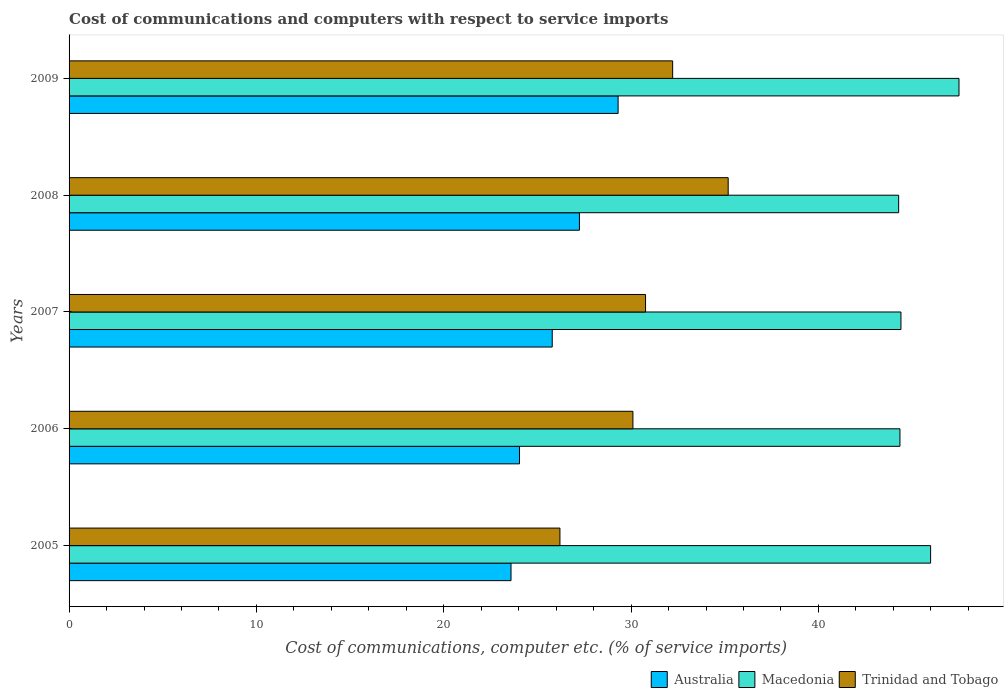How many groups of bars are there?
Your response must be concise. 5. How many bars are there on the 3rd tick from the top?
Keep it short and to the point. 3. What is the cost of communications and computers in Trinidad and Tobago in 2009?
Give a very brief answer. 32.22. Across all years, what is the maximum cost of communications and computers in Macedonia?
Ensure brevity in your answer.  47.51. Across all years, what is the minimum cost of communications and computers in Australia?
Ensure brevity in your answer.  23.59. What is the total cost of communications and computers in Trinidad and Tobago in the graph?
Offer a terse response. 154.48. What is the difference between the cost of communications and computers in Macedonia in 2007 and that in 2008?
Provide a short and direct response. 0.12. What is the difference between the cost of communications and computers in Trinidad and Tobago in 2006 and the cost of communications and computers in Australia in 2005?
Keep it short and to the point. 6.51. What is the average cost of communications and computers in Australia per year?
Your response must be concise. 26. In the year 2009, what is the difference between the cost of communications and computers in Australia and cost of communications and computers in Trinidad and Tobago?
Your answer should be compact. -2.91. What is the ratio of the cost of communications and computers in Australia in 2006 to that in 2009?
Keep it short and to the point. 0.82. Is the cost of communications and computers in Trinidad and Tobago in 2006 less than that in 2009?
Provide a short and direct response. Yes. Is the difference between the cost of communications and computers in Australia in 2007 and 2009 greater than the difference between the cost of communications and computers in Trinidad and Tobago in 2007 and 2009?
Provide a succinct answer. No. What is the difference between the highest and the second highest cost of communications and computers in Australia?
Give a very brief answer. 2.06. What is the difference between the highest and the lowest cost of communications and computers in Macedonia?
Keep it short and to the point. 3.22. In how many years, is the cost of communications and computers in Trinidad and Tobago greater than the average cost of communications and computers in Trinidad and Tobago taken over all years?
Keep it short and to the point. 2. Is the sum of the cost of communications and computers in Macedonia in 2005 and 2006 greater than the maximum cost of communications and computers in Trinidad and Tobago across all years?
Offer a terse response. Yes. What does the 2nd bar from the top in 2009 represents?
Your answer should be compact. Macedonia. What does the 2nd bar from the bottom in 2009 represents?
Keep it short and to the point. Macedonia. How many bars are there?
Keep it short and to the point. 15. How many years are there in the graph?
Provide a short and direct response. 5. Does the graph contain any zero values?
Provide a succinct answer. No. Does the graph contain grids?
Provide a short and direct response. No. How many legend labels are there?
Your answer should be compact. 3. How are the legend labels stacked?
Offer a terse response. Horizontal. What is the title of the graph?
Offer a terse response. Cost of communications and computers with respect to service imports. What is the label or title of the X-axis?
Keep it short and to the point. Cost of communications, computer etc. (% of service imports). What is the Cost of communications, computer etc. (% of service imports) in Australia in 2005?
Your response must be concise. 23.59. What is the Cost of communications, computer etc. (% of service imports) in Macedonia in 2005?
Your answer should be very brief. 45.99. What is the Cost of communications, computer etc. (% of service imports) in Trinidad and Tobago in 2005?
Offer a terse response. 26.2. What is the Cost of communications, computer etc. (% of service imports) of Australia in 2006?
Your answer should be very brief. 24.05. What is the Cost of communications, computer etc. (% of service imports) of Macedonia in 2006?
Ensure brevity in your answer.  44.35. What is the Cost of communications, computer etc. (% of service imports) in Trinidad and Tobago in 2006?
Your response must be concise. 30.1. What is the Cost of communications, computer etc. (% of service imports) of Australia in 2007?
Your answer should be very brief. 25.79. What is the Cost of communications, computer etc. (% of service imports) of Macedonia in 2007?
Your response must be concise. 44.41. What is the Cost of communications, computer etc. (% of service imports) in Trinidad and Tobago in 2007?
Your answer should be very brief. 30.77. What is the Cost of communications, computer etc. (% of service imports) of Australia in 2008?
Your answer should be compact. 27.24. What is the Cost of communications, computer etc. (% of service imports) in Macedonia in 2008?
Provide a succinct answer. 44.28. What is the Cost of communications, computer etc. (% of service imports) of Trinidad and Tobago in 2008?
Keep it short and to the point. 35.18. What is the Cost of communications, computer etc. (% of service imports) in Australia in 2009?
Offer a very short reply. 29.31. What is the Cost of communications, computer etc. (% of service imports) in Macedonia in 2009?
Your answer should be very brief. 47.51. What is the Cost of communications, computer etc. (% of service imports) in Trinidad and Tobago in 2009?
Offer a terse response. 32.22. Across all years, what is the maximum Cost of communications, computer etc. (% of service imports) of Australia?
Your response must be concise. 29.31. Across all years, what is the maximum Cost of communications, computer etc. (% of service imports) in Macedonia?
Offer a very short reply. 47.51. Across all years, what is the maximum Cost of communications, computer etc. (% of service imports) in Trinidad and Tobago?
Your answer should be very brief. 35.18. Across all years, what is the minimum Cost of communications, computer etc. (% of service imports) in Australia?
Keep it short and to the point. 23.59. Across all years, what is the minimum Cost of communications, computer etc. (% of service imports) of Macedonia?
Provide a succinct answer. 44.28. Across all years, what is the minimum Cost of communications, computer etc. (% of service imports) of Trinidad and Tobago?
Give a very brief answer. 26.2. What is the total Cost of communications, computer etc. (% of service imports) of Australia in the graph?
Give a very brief answer. 129.98. What is the total Cost of communications, computer etc. (% of service imports) of Macedonia in the graph?
Your answer should be compact. 226.54. What is the total Cost of communications, computer etc. (% of service imports) in Trinidad and Tobago in the graph?
Keep it short and to the point. 154.48. What is the difference between the Cost of communications, computer etc. (% of service imports) in Australia in 2005 and that in 2006?
Provide a short and direct response. -0.45. What is the difference between the Cost of communications, computer etc. (% of service imports) of Macedonia in 2005 and that in 2006?
Offer a very short reply. 1.64. What is the difference between the Cost of communications, computer etc. (% of service imports) of Trinidad and Tobago in 2005 and that in 2006?
Offer a very short reply. -3.9. What is the difference between the Cost of communications, computer etc. (% of service imports) of Australia in 2005 and that in 2007?
Provide a short and direct response. -2.2. What is the difference between the Cost of communications, computer etc. (% of service imports) of Macedonia in 2005 and that in 2007?
Offer a terse response. 1.58. What is the difference between the Cost of communications, computer etc. (% of service imports) of Trinidad and Tobago in 2005 and that in 2007?
Make the answer very short. -4.57. What is the difference between the Cost of communications, computer etc. (% of service imports) in Australia in 2005 and that in 2008?
Give a very brief answer. -3.65. What is the difference between the Cost of communications, computer etc. (% of service imports) in Macedonia in 2005 and that in 2008?
Provide a short and direct response. 1.71. What is the difference between the Cost of communications, computer etc. (% of service imports) of Trinidad and Tobago in 2005 and that in 2008?
Provide a short and direct response. -8.98. What is the difference between the Cost of communications, computer etc. (% of service imports) of Australia in 2005 and that in 2009?
Offer a terse response. -5.72. What is the difference between the Cost of communications, computer etc. (% of service imports) in Macedonia in 2005 and that in 2009?
Your response must be concise. -1.51. What is the difference between the Cost of communications, computer etc. (% of service imports) of Trinidad and Tobago in 2005 and that in 2009?
Offer a very short reply. -6.02. What is the difference between the Cost of communications, computer etc. (% of service imports) in Australia in 2006 and that in 2007?
Ensure brevity in your answer.  -1.75. What is the difference between the Cost of communications, computer etc. (% of service imports) of Macedonia in 2006 and that in 2007?
Provide a short and direct response. -0.05. What is the difference between the Cost of communications, computer etc. (% of service imports) in Trinidad and Tobago in 2006 and that in 2007?
Give a very brief answer. -0.67. What is the difference between the Cost of communications, computer etc. (% of service imports) of Australia in 2006 and that in 2008?
Offer a very short reply. -3.2. What is the difference between the Cost of communications, computer etc. (% of service imports) in Macedonia in 2006 and that in 2008?
Your answer should be compact. 0.07. What is the difference between the Cost of communications, computer etc. (% of service imports) in Trinidad and Tobago in 2006 and that in 2008?
Offer a terse response. -5.08. What is the difference between the Cost of communications, computer etc. (% of service imports) of Australia in 2006 and that in 2009?
Offer a terse response. -5.26. What is the difference between the Cost of communications, computer etc. (% of service imports) of Macedonia in 2006 and that in 2009?
Provide a succinct answer. -3.15. What is the difference between the Cost of communications, computer etc. (% of service imports) in Trinidad and Tobago in 2006 and that in 2009?
Provide a succinct answer. -2.12. What is the difference between the Cost of communications, computer etc. (% of service imports) of Australia in 2007 and that in 2008?
Make the answer very short. -1.45. What is the difference between the Cost of communications, computer etc. (% of service imports) in Macedonia in 2007 and that in 2008?
Keep it short and to the point. 0.12. What is the difference between the Cost of communications, computer etc. (% of service imports) of Trinidad and Tobago in 2007 and that in 2008?
Keep it short and to the point. -4.41. What is the difference between the Cost of communications, computer etc. (% of service imports) of Australia in 2007 and that in 2009?
Make the answer very short. -3.52. What is the difference between the Cost of communications, computer etc. (% of service imports) of Macedonia in 2007 and that in 2009?
Provide a succinct answer. -3.1. What is the difference between the Cost of communications, computer etc. (% of service imports) in Trinidad and Tobago in 2007 and that in 2009?
Keep it short and to the point. -1.45. What is the difference between the Cost of communications, computer etc. (% of service imports) in Australia in 2008 and that in 2009?
Provide a succinct answer. -2.06. What is the difference between the Cost of communications, computer etc. (% of service imports) of Macedonia in 2008 and that in 2009?
Your answer should be compact. -3.22. What is the difference between the Cost of communications, computer etc. (% of service imports) of Trinidad and Tobago in 2008 and that in 2009?
Offer a terse response. 2.96. What is the difference between the Cost of communications, computer etc. (% of service imports) of Australia in 2005 and the Cost of communications, computer etc. (% of service imports) of Macedonia in 2006?
Provide a succinct answer. -20.76. What is the difference between the Cost of communications, computer etc. (% of service imports) in Australia in 2005 and the Cost of communications, computer etc. (% of service imports) in Trinidad and Tobago in 2006?
Ensure brevity in your answer.  -6.51. What is the difference between the Cost of communications, computer etc. (% of service imports) in Macedonia in 2005 and the Cost of communications, computer etc. (% of service imports) in Trinidad and Tobago in 2006?
Your answer should be compact. 15.89. What is the difference between the Cost of communications, computer etc. (% of service imports) of Australia in 2005 and the Cost of communications, computer etc. (% of service imports) of Macedonia in 2007?
Provide a succinct answer. -20.81. What is the difference between the Cost of communications, computer etc. (% of service imports) in Australia in 2005 and the Cost of communications, computer etc. (% of service imports) in Trinidad and Tobago in 2007?
Provide a short and direct response. -7.18. What is the difference between the Cost of communications, computer etc. (% of service imports) of Macedonia in 2005 and the Cost of communications, computer etc. (% of service imports) of Trinidad and Tobago in 2007?
Keep it short and to the point. 15.22. What is the difference between the Cost of communications, computer etc. (% of service imports) in Australia in 2005 and the Cost of communications, computer etc. (% of service imports) in Macedonia in 2008?
Keep it short and to the point. -20.69. What is the difference between the Cost of communications, computer etc. (% of service imports) of Australia in 2005 and the Cost of communications, computer etc. (% of service imports) of Trinidad and Tobago in 2008?
Ensure brevity in your answer.  -11.59. What is the difference between the Cost of communications, computer etc. (% of service imports) of Macedonia in 2005 and the Cost of communications, computer etc. (% of service imports) of Trinidad and Tobago in 2008?
Make the answer very short. 10.81. What is the difference between the Cost of communications, computer etc. (% of service imports) of Australia in 2005 and the Cost of communications, computer etc. (% of service imports) of Macedonia in 2009?
Ensure brevity in your answer.  -23.91. What is the difference between the Cost of communications, computer etc. (% of service imports) of Australia in 2005 and the Cost of communications, computer etc. (% of service imports) of Trinidad and Tobago in 2009?
Your answer should be very brief. -8.63. What is the difference between the Cost of communications, computer etc. (% of service imports) in Macedonia in 2005 and the Cost of communications, computer etc. (% of service imports) in Trinidad and Tobago in 2009?
Offer a terse response. 13.77. What is the difference between the Cost of communications, computer etc. (% of service imports) of Australia in 2006 and the Cost of communications, computer etc. (% of service imports) of Macedonia in 2007?
Keep it short and to the point. -20.36. What is the difference between the Cost of communications, computer etc. (% of service imports) of Australia in 2006 and the Cost of communications, computer etc. (% of service imports) of Trinidad and Tobago in 2007?
Provide a short and direct response. -6.73. What is the difference between the Cost of communications, computer etc. (% of service imports) in Macedonia in 2006 and the Cost of communications, computer etc. (% of service imports) in Trinidad and Tobago in 2007?
Ensure brevity in your answer.  13.58. What is the difference between the Cost of communications, computer etc. (% of service imports) of Australia in 2006 and the Cost of communications, computer etc. (% of service imports) of Macedonia in 2008?
Your response must be concise. -20.24. What is the difference between the Cost of communications, computer etc. (% of service imports) in Australia in 2006 and the Cost of communications, computer etc. (% of service imports) in Trinidad and Tobago in 2008?
Ensure brevity in your answer.  -11.14. What is the difference between the Cost of communications, computer etc. (% of service imports) in Macedonia in 2006 and the Cost of communications, computer etc. (% of service imports) in Trinidad and Tobago in 2008?
Provide a short and direct response. 9.17. What is the difference between the Cost of communications, computer etc. (% of service imports) of Australia in 2006 and the Cost of communications, computer etc. (% of service imports) of Macedonia in 2009?
Ensure brevity in your answer.  -23.46. What is the difference between the Cost of communications, computer etc. (% of service imports) in Australia in 2006 and the Cost of communications, computer etc. (% of service imports) in Trinidad and Tobago in 2009?
Provide a succinct answer. -8.17. What is the difference between the Cost of communications, computer etc. (% of service imports) of Macedonia in 2006 and the Cost of communications, computer etc. (% of service imports) of Trinidad and Tobago in 2009?
Provide a short and direct response. 12.13. What is the difference between the Cost of communications, computer etc. (% of service imports) of Australia in 2007 and the Cost of communications, computer etc. (% of service imports) of Macedonia in 2008?
Provide a short and direct response. -18.49. What is the difference between the Cost of communications, computer etc. (% of service imports) of Australia in 2007 and the Cost of communications, computer etc. (% of service imports) of Trinidad and Tobago in 2008?
Provide a short and direct response. -9.39. What is the difference between the Cost of communications, computer etc. (% of service imports) of Macedonia in 2007 and the Cost of communications, computer etc. (% of service imports) of Trinidad and Tobago in 2008?
Offer a very short reply. 9.22. What is the difference between the Cost of communications, computer etc. (% of service imports) of Australia in 2007 and the Cost of communications, computer etc. (% of service imports) of Macedonia in 2009?
Provide a short and direct response. -21.71. What is the difference between the Cost of communications, computer etc. (% of service imports) in Australia in 2007 and the Cost of communications, computer etc. (% of service imports) in Trinidad and Tobago in 2009?
Keep it short and to the point. -6.43. What is the difference between the Cost of communications, computer etc. (% of service imports) of Macedonia in 2007 and the Cost of communications, computer etc. (% of service imports) of Trinidad and Tobago in 2009?
Offer a terse response. 12.19. What is the difference between the Cost of communications, computer etc. (% of service imports) in Australia in 2008 and the Cost of communications, computer etc. (% of service imports) in Macedonia in 2009?
Make the answer very short. -20.26. What is the difference between the Cost of communications, computer etc. (% of service imports) of Australia in 2008 and the Cost of communications, computer etc. (% of service imports) of Trinidad and Tobago in 2009?
Your response must be concise. -4.98. What is the difference between the Cost of communications, computer etc. (% of service imports) of Macedonia in 2008 and the Cost of communications, computer etc. (% of service imports) of Trinidad and Tobago in 2009?
Keep it short and to the point. 12.06. What is the average Cost of communications, computer etc. (% of service imports) of Australia per year?
Ensure brevity in your answer.  26. What is the average Cost of communications, computer etc. (% of service imports) in Macedonia per year?
Your answer should be compact. 45.31. What is the average Cost of communications, computer etc. (% of service imports) of Trinidad and Tobago per year?
Offer a very short reply. 30.9. In the year 2005, what is the difference between the Cost of communications, computer etc. (% of service imports) in Australia and Cost of communications, computer etc. (% of service imports) in Macedonia?
Make the answer very short. -22.4. In the year 2005, what is the difference between the Cost of communications, computer etc. (% of service imports) in Australia and Cost of communications, computer etc. (% of service imports) in Trinidad and Tobago?
Offer a terse response. -2.61. In the year 2005, what is the difference between the Cost of communications, computer etc. (% of service imports) in Macedonia and Cost of communications, computer etc. (% of service imports) in Trinidad and Tobago?
Keep it short and to the point. 19.79. In the year 2006, what is the difference between the Cost of communications, computer etc. (% of service imports) in Australia and Cost of communications, computer etc. (% of service imports) in Macedonia?
Ensure brevity in your answer.  -20.31. In the year 2006, what is the difference between the Cost of communications, computer etc. (% of service imports) of Australia and Cost of communications, computer etc. (% of service imports) of Trinidad and Tobago?
Provide a short and direct response. -6.05. In the year 2006, what is the difference between the Cost of communications, computer etc. (% of service imports) in Macedonia and Cost of communications, computer etc. (% of service imports) in Trinidad and Tobago?
Provide a short and direct response. 14.25. In the year 2007, what is the difference between the Cost of communications, computer etc. (% of service imports) in Australia and Cost of communications, computer etc. (% of service imports) in Macedonia?
Your answer should be compact. -18.61. In the year 2007, what is the difference between the Cost of communications, computer etc. (% of service imports) of Australia and Cost of communications, computer etc. (% of service imports) of Trinidad and Tobago?
Give a very brief answer. -4.98. In the year 2007, what is the difference between the Cost of communications, computer etc. (% of service imports) in Macedonia and Cost of communications, computer etc. (% of service imports) in Trinidad and Tobago?
Provide a short and direct response. 13.63. In the year 2008, what is the difference between the Cost of communications, computer etc. (% of service imports) in Australia and Cost of communications, computer etc. (% of service imports) in Macedonia?
Your response must be concise. -17.04. In the year 2008, what is the difference between the Cost of communications, computer etc. (% of service imports) of Australia and Cost of communications, computer etc. (% of service imports) of Trinidad and Tobago?
Your response must be concise. -7.94. In the year 2008, what is the difference between the Cost of communications, computer etc. (% of service imports) in Macedonia and Cost of communications, computer etc. (% of service imports) in Trinidad and Tobago?
Give a very brief answer. 9.1. In the year 2009, what is the difference between the Cost of communications, computer etc. (% of service imports) of Australia and Cost of communications, computer etc. (% of service imports) of Macedonia?
Offer a very short reply. -18.2. In the year 2009, what is the difference between the Cost of communications, computer etc. (% of service imports) in Australia and Cost of communications, computer etc. (% of service imports) in Trinidad and Tobago?
Give a very brief answer. -2.91. In the year 2009, what is the difference between the Cost of communications, computer etc. (% of service imports) of Macedonia and Cost of communications, computer etc. (% of service imports) of Trinidad and Tobago?
Offer a very short reply. 15.29. What is the ratio of the Cost of communications, computer etc. (% of service imports) of Australia in 2005 to that in 2006?
Your response must be concise. 0.98. What is the ratio of the Cost of communications, computer etc. (% of service imports) in Macedonia in 2005 to that in 2006?
Provide a succinct answer. 1.04. What is the ratio of the Cost of communications, computer etc. (% of service imports) of Trinidad and Tobago in 2005 to that in 2006?
Provide a succinct answer. 0.87. What is the ratio of the Cost of communications, computer etc. (% of service imports) in Australia in 2005 to that in 2007?
Your response must be concise. 0.91. What is the ratio of the Cost of communications, computer etc. (% of service imports) of Macedonia in 2005 to that in 2007?
Your answer should be very brief. 1.04. What is the ratio of the Cost of communications, computer etc. (% of service imports) of Trinidad and Tobago in 2005 to that in 2007?
Offer a very short reply. 0.85. What is the ratio of the Cost of communications, computer etc. (% of service imports) of Australia in 2005 to that in 2008?
Your response must be concise. 0.87. What is the ratio of the Cost of communications, computer etc. (% of service imports) of Macedonia in 2005 to that in 2008?
Give a very brief answer. 1.04. What is the ratio of the Cost of communications, computer etc. (% of service imports) of Trinidad and Tobago in 2005 to that in 2008?
Your answer should be compact. 0.74. What is the ratio of the Cost of communications, computer etc. (% of service imports) in Australia in 2005 to that in 2009?
Your answer should be compact. 0.8. What is the ratio of the Cost of communications, computer etc. (% of service imports) of Macedonia in 2005 to that in 2009?
Offer a very short reply. 0.97. What is the ratio of the Cost of communications, computer etc. (% of service imports) in Trinidad and Tobago in 2005 to that in 2009?
Give a very brief answer. 0.81. What is the ratio of the Cost of communications, computer etc. (% of service imports) of Australia in 2006 to that in 2007?
Ensure brevity in your answer.  0.93. What is the ratio of the Cost of communications, computer etc. (% of service imports) in Trinidad and Tobago in 2006 to that in 2007?
Offer a very short reply. 0.98. What is the ratio of the Cost of communications, computer etc. (% of service imports) in Australia in 2006 to that in 2008?
Your response must be concise. 0.88. What is the ratio of the Cost of communications, computer etc. (% of service imports) in Trinidad and Tobago in 2006 to that in 2008?
Your answer should be compact. 0.86. What is the ratio of the Cost of communications, computer etc. (% of service imports) in Australia in 2006 to that in 2009?
Make the answer very short. 0.82. What is the ratio of the Cost of communications, computer etc. (% of service imports) of Macedonia in 2006 to that in 2009?
Offer a terse response. 0.93. What is the ratio of the Cost of communications, computer etc. (% of service imports) in Trinidad and Tobago in 2006 to that in 2009?
Make the answer very short. 0.93. What is the ratio of the Cost of communications, computer etc. (% of service imports) in Australia in 2007 to that in 2008?
Give a very brief answer. 0.95. What is the ratio of the Cost of communications, computer etc. (% of service imports) in Macedonia in 2007 to that in 2008?
Ensure brevity in your answer.  1. What is the ratio of the Cost of communications, computer etc. (% of service imports) of Trinidad and Tobago in 2007 to that in 2008?
Offer a terse response. 0.87. What is the ratio of the Cost of communications, computer etc. (% of service imports) of Australia in 2007 to that in 2009?
Offer a terse response. 0.88. What is the ratio of the Cost of communications, computer etc. (% of service imports) in Macedonia in 2007 to that in 2009?
Keep it short and to the point. 0.93. What is the ratio of the Cost of communications, computer etc. (% of service imports) of Trinidad and Tobago in 2007 to that in 2009?
Give a very brief answer. 0.96. What is the ratio of the Cost of communications, computer etc. (% of service imports) in Australia in 2008 to that in 2009?
Keep it short and to the point. 0.93. What is the ratio of the Cost of communications, computer etc. (% of service imports) of Macedonia in 2008 to that in 2009?
Offer a very short reply. 0.93. What is the ratio of the Cost of communications, computer etc. (% of service imports) in Trinidad and Tobago in 2008 to that in 2009?
Keep it short and to the point. 1.09. What is the difference between the highest and the second highest Cost of communications, computer etc. (% of service imports) in Australia?
Offer a terse response. 2.06. What is the difference between the highest and the second highest Cost of communications, computer etc. (% of service imports) of Macedonia?
Offer a very short reply. 1.51. What is the difference between the highest and the second highest Cost of communications, computer etc. (% of service imports) of Trinidad and Tobago?
Your answer should be very brief. 2.96. What is the difference between the highest and the lowest Cost of communications, computer etc. (% of service imports) of Australia?
Ensure brevity in your answer.  5.72. What is the difference between the highest and the lowest Cost of communications, computer etc. (% of service imports) of Macedonia?
Provide a succinct answer. 3.22. What is the difference between the highest and the lowest Cost of communications, computer etc. (% of service imports) of Trinidad and Tobago?
Ensure brevity in your answer.  8.98. 